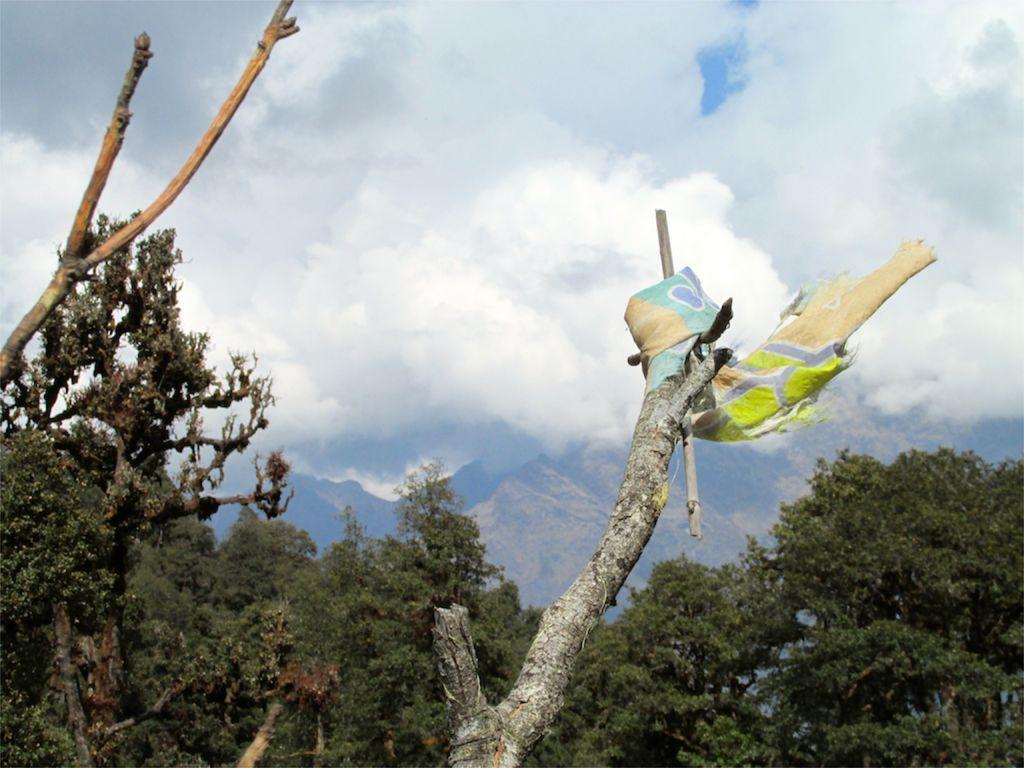Can you describe this image briefly? In this image there are trees and there is a cloth on the one of the trees. In the background there are mountains and the sky. 